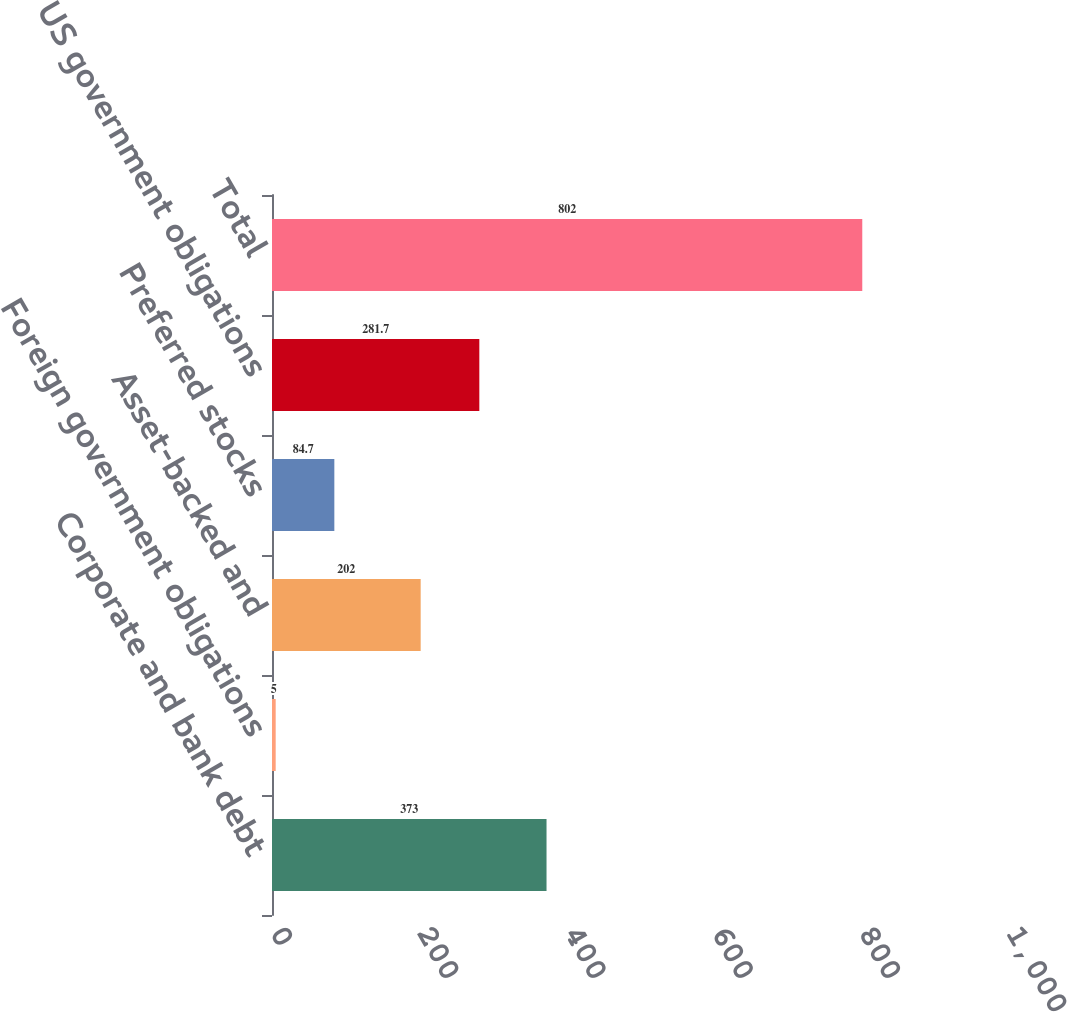<chart> <loc_0><loc_0><loc_500><loc_500><bar_chart><fcel>Corporate and bank debt<fcel>Foreign government obligations<fcel>Asset-backed and<fcel>Preferred stocks<fcel>US government obligations<fcel>Total<nl><fcel>373<fcel>5<fcel>202<fcel>84.7<fcel>281.7<fcel>802<nl></chart> 